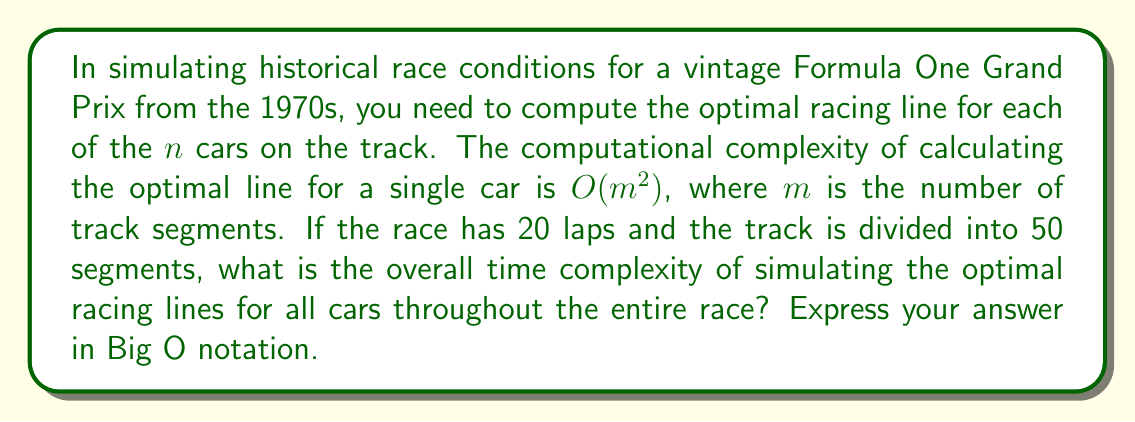Give your solution to this math problem. Let's break this problem down step-by-step:

1) First, we need to understand the given information:
   - There are $n$ cars
   - The complexity for calculating the optimal line for one car is $O(m^2)$
   - The track has 50 segments, so $m = 50$
   - The race has 20 laps

2) For a single car on a single lap:
   - The complexity is $O(m^2) = O(50^2) = O(2500)$

3) For a single car for the entire race (20 laps):
   - We multiply the complexity by the number of laps
   - $O(2500 * 20) = O(50000)$

4) Now, we need to do this for all $n$ cars:
   - We multiply the complexity by $n$
   - $O(50000n) = O(n)$

5) Simplifying:
   - The constant factors (50000 in this case) are dropped in Big O notation
   - Therefore, the final complexity is $O(n)$

This means the time complexity grows linearly with the number of cars, which is efficient considering the detailed nature of the simulation.
Answer: $O(n)$ 